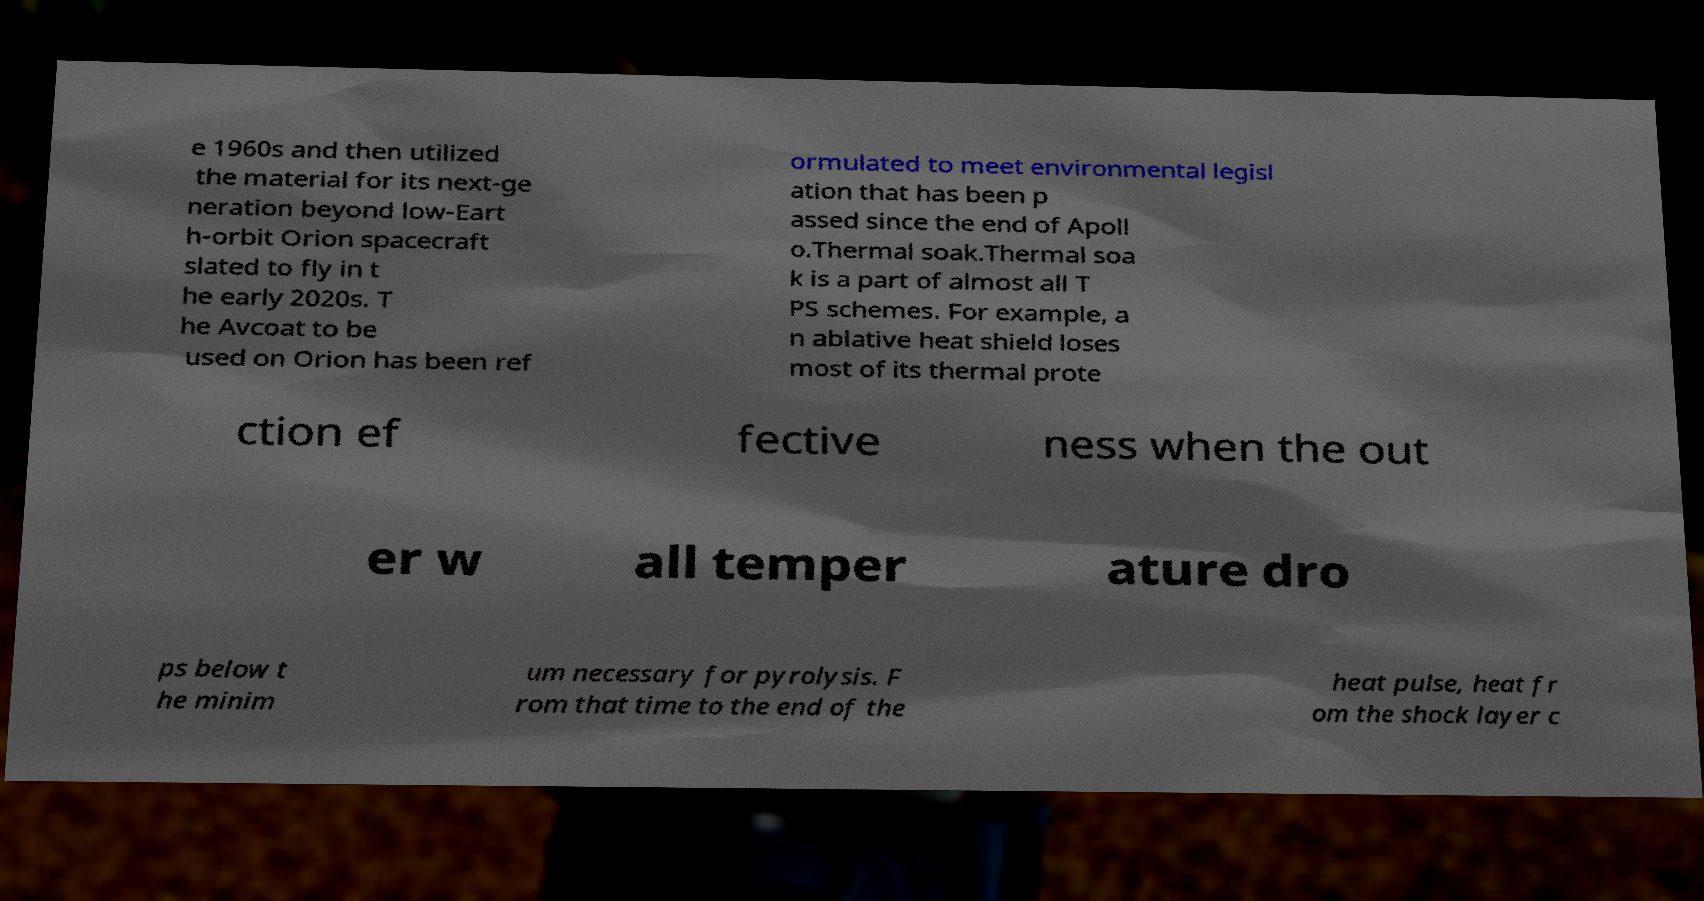I need the written content from this picture converted into text. Can you do that? e 1960s and then utilized the material for its next-ge neration beyond low-Eart h-orbit Orion spacecraft slated to fly in t he early 2020s. T he Avcoat to be used on Orion has been ref ormulated to meet environmental legisl ation that has been p assed since the end of Apoll o.Thermal soak.Thermal soa k is a part of almost all T PS schemes. For example, a n ablative heat shield loses most of its thermal prote ction ef fective ness when the out er w all temper ature dro ps below t he minim um necessary for pyrolysis. F rom that time to the end of the heat pulse, heat fr om the shock layer c 